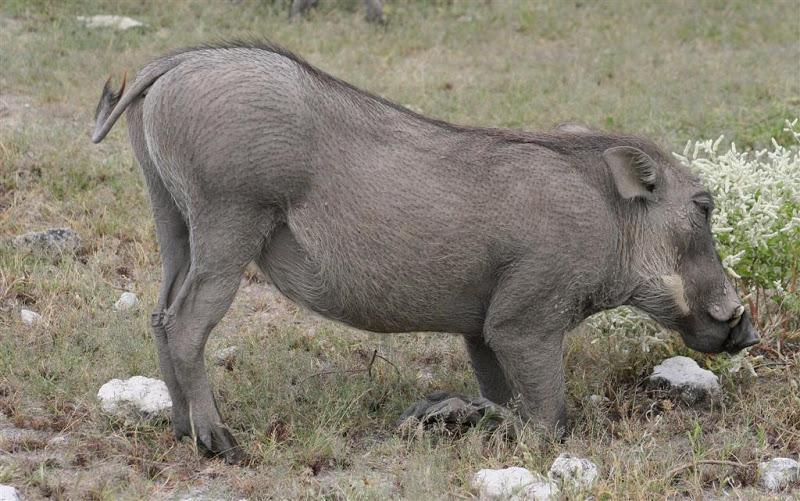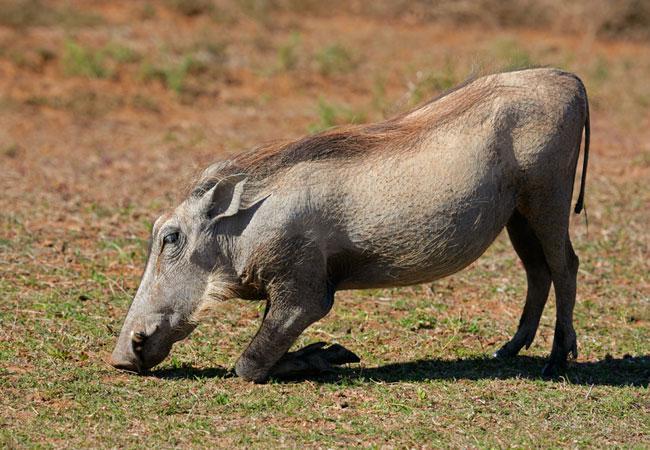The first image is the image on the left, the second image is the image on the right. Evaluate the accuracy of this statement regarding the images: "A group of four or more animals stands in a field.". Is it true? Answer yes or no. No. 